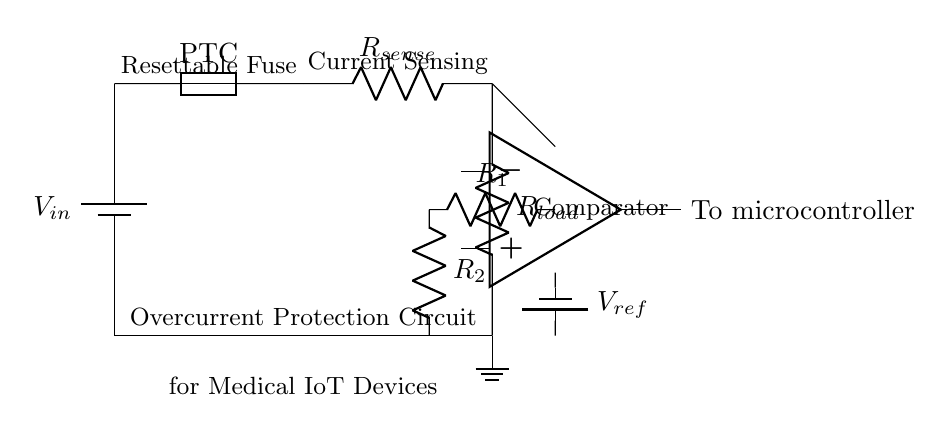What is the main function of the resettable fuse in this circuit? The resettable fuse serves as a current protection device that opens the circuit when excessive current flows, preventing damage to the medical IoT device.
Answer: Current protection What component is used to sense current in this circuit? The current sensing resistor, labeled R_sense, is used to measure the current flowing through the circuit and provides a means to detect overcurrent conditions.
Answer: R_sense What type of comparator is used in this circuit? The circuit uses an operational amplifier configured as a comparator to compare the sensed voltage across R_sense with a reference voltage.
Answer: Operational amplifier What happens if the current exceeds the rated value? If the current exceeds the rated value, the resettable fuse will trip, interrupting the circuit to prevent further current flow and potential damage.
Answer: Fuse trips What is the reference voltage supplied to the comparator? The reference voltage, labeled V_ref, is supplied to set the threshold for the comparator to determine if the sensed current exceeds the allowable limits.
Answer: V_ref Which component indicates a fault condition in this circuit? The output from the operational amplifier (comparator) indicates a fault condition when the sensed current exceeds the reference voltage; this is sent to the microcontroller.
Answer: Comparator output 